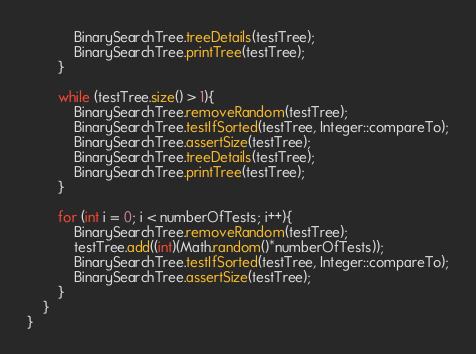<code> <loc_0><loc_0><loc_500><loc_500><_Java_>            BinarySearchTree.treeDetails(testTree);
            BinarySearchTree.printTree(testTree);
        }

        while (testTree.size() > 1){
            BinarySearchTree.removeRandom(testTree);
            BinarySearchTree.testIfSorted(testTree, Integer::compareTo);
            BinarySearchTree.assertSize(testTree);
            BinarySearchTree.treeDetails(testTree);
            BinarySearchTree.printTree(testTree);
        }

        for (int i = 0; i < numberOfTests; i++){
            BinarySearchTree.removeRandom(testTree);
            testTree.add((int)(Math.random()*numberOfTests));
            BinarySearchTree.testIfSorted(testTree, Integer::compareTo);
            BinarySearchTree.assertSize(testTree);
        }
    }
}</code> 